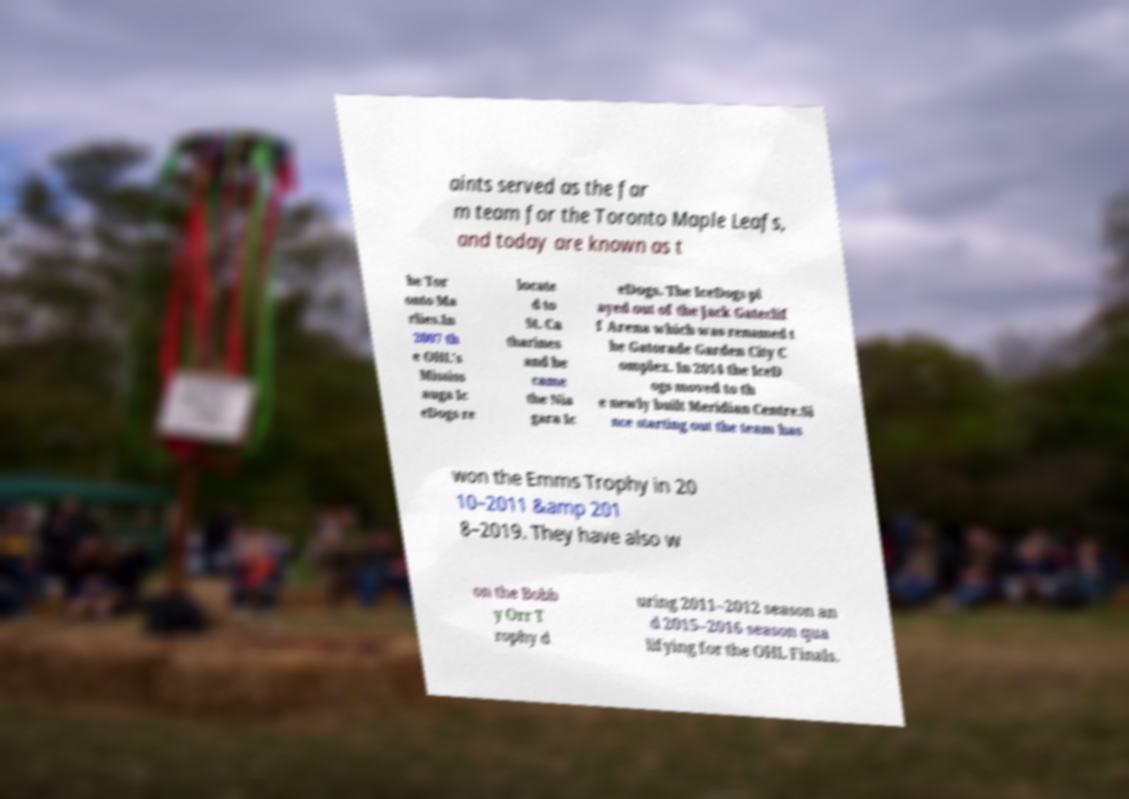Could you assist in decoding the text presented in this image and type it out clearly? aints served as the far m team for the Toronto Maple Leafs, and today are known as t he Tor onto Ma rlies.In 2007 th e OHL's Mississ auga Ic eDogs re locate d to St. Ca tharines and be came the Nia gara Ic eDogs. The IceDogs pl ayed out of the Jack Gateclif f Arena which was renamed t he Gatorade Garden City C omplex. In 2014 the IceD ogs moved to th e newly built Meridian Centre.Si nce starting out the team has won the Emms Trophy in 20 10–2011 &amp 201 8–2019. They have also w on the Bobb y Orr T rophy d uring 2011–2012 season an d 2015–2016 season qua lifying for the OHL Finals. 